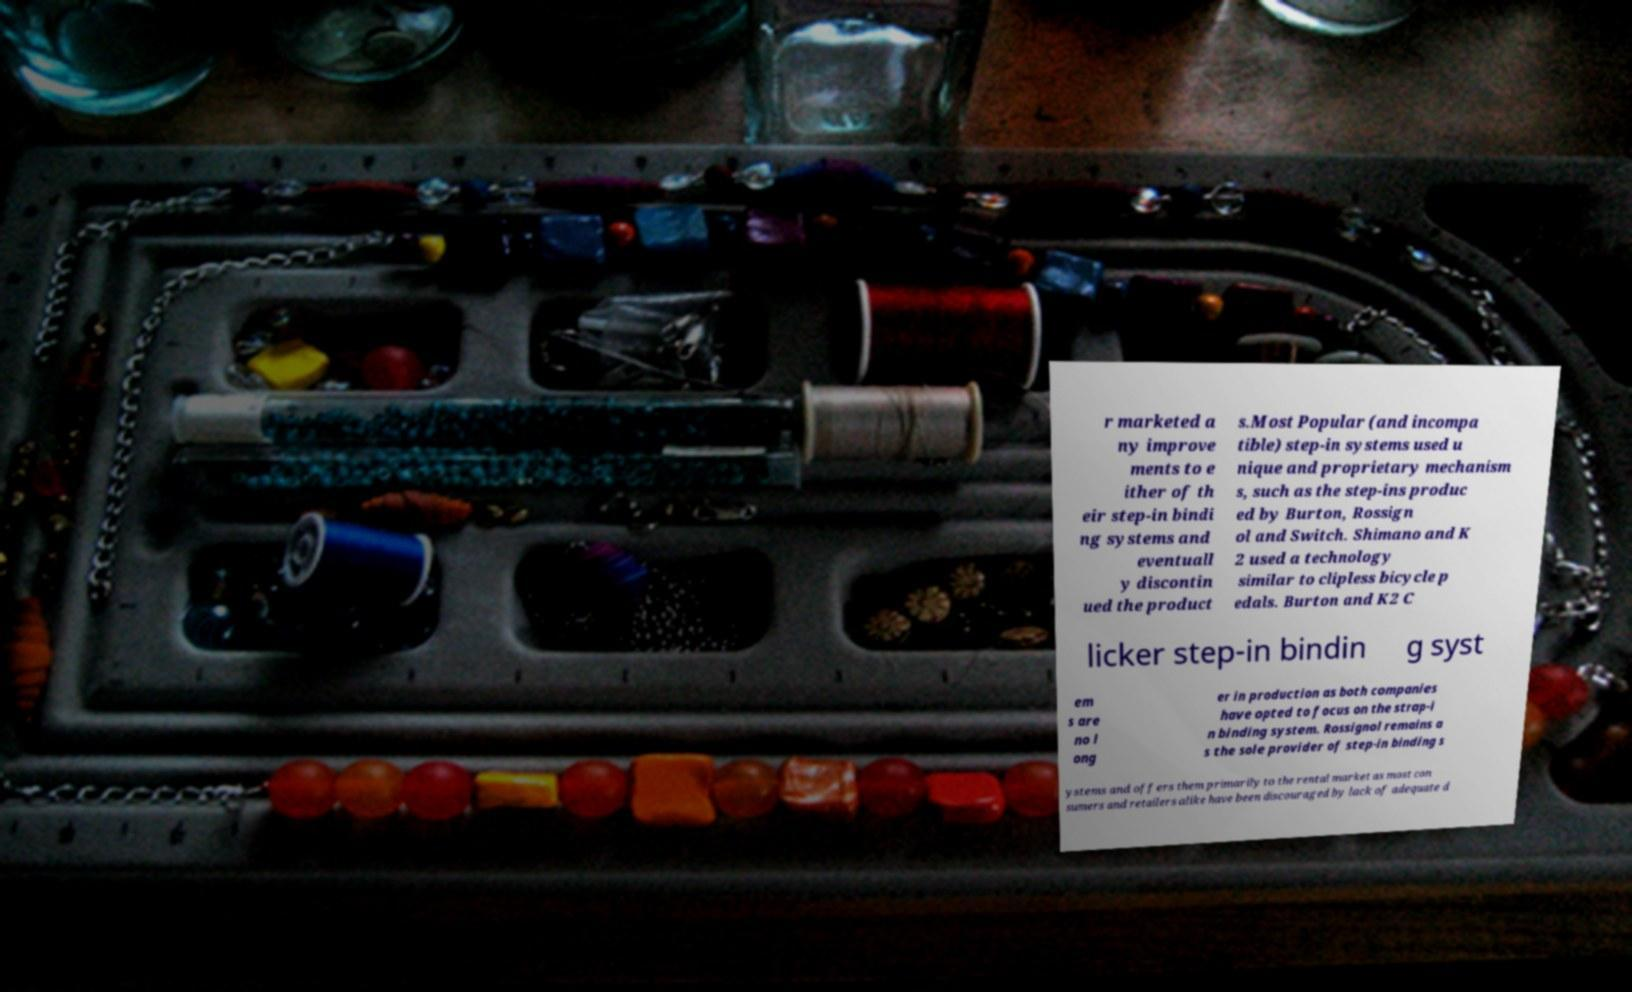Can you read and provide the text displayed in the image?This photo seems to have some interesting text. Can you extract and type it out for me? r marketed a ny improve ments to e ither of th eir step-in bindi ng systems and eventuall y discontin ued the product s.Most Popular (and incompa tible) step-in systems used u nique and proprietary mechanism s, such as the step-ins produc ed by Burton, Rossign ol and Switch. Shimano and K 2 used a technology similar to clipless bicycle p edals. Burton and K2 C licker step-in bindin g syst em s are no l ong er in production as both companies have opted to focus on the strap-i n binding system. Rossignol remains a s the sole provider of step-in binding s ystems and offers them primarily to the rental market as most con sumers and retailers alike have been discouraged by lack of adequate d 